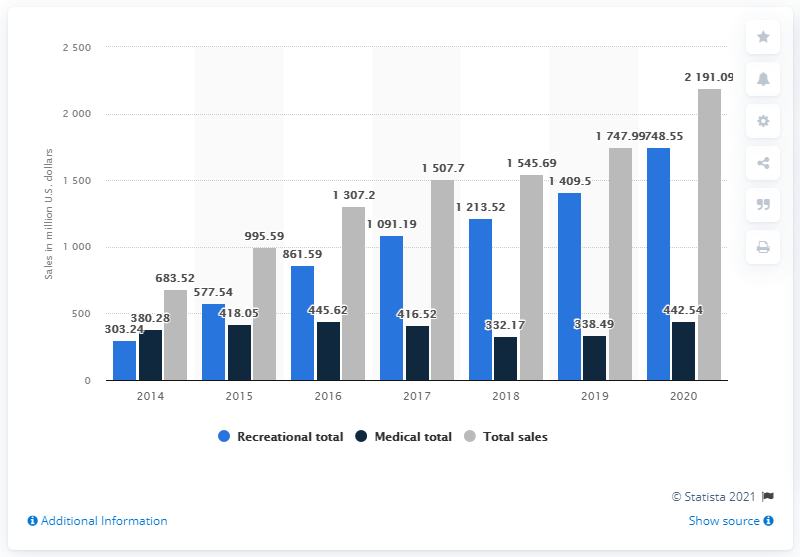Identify some key points in this picture. According to the data, the total marijuana sales in Colorado in 2020 were 2,191.09. 